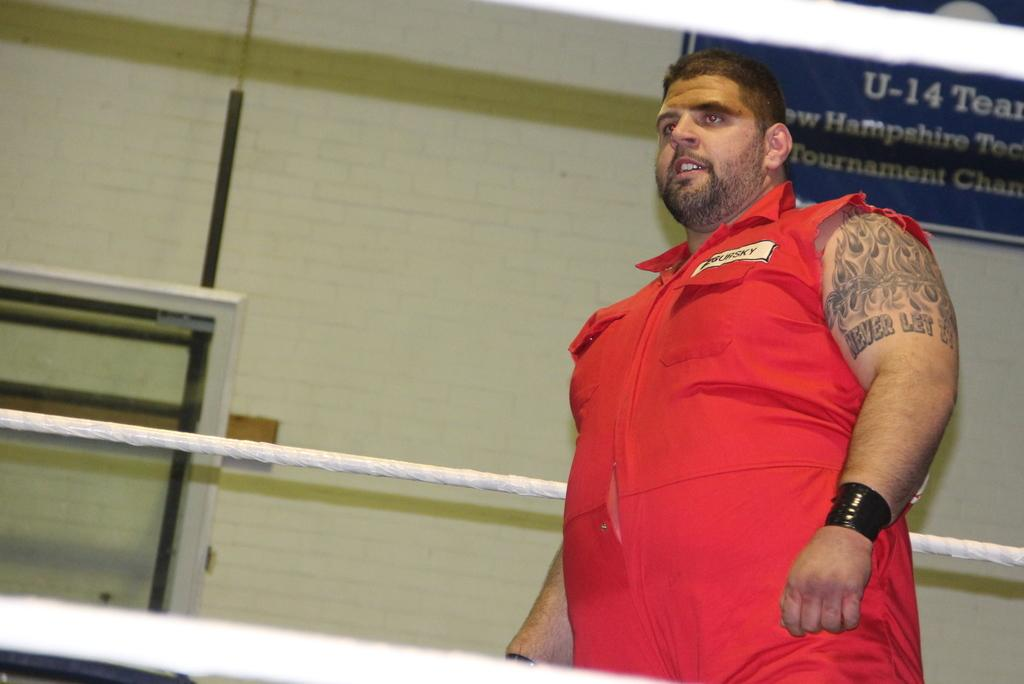<image>
Give a short and clear explanation of the subsequent image. Man with tattoos standing in front of a blue sign that says U-14. 